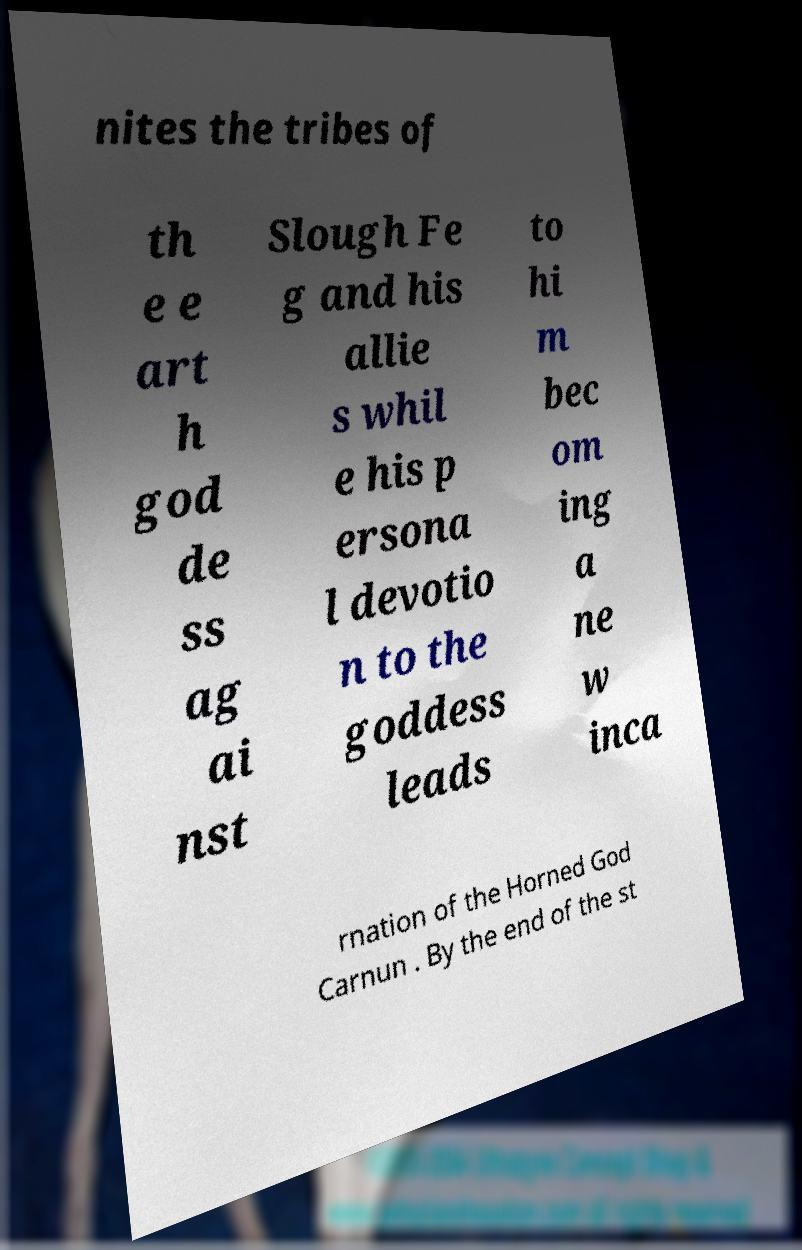I need the written content from this picture converted into text. Can you do that? nites the tribes of th e e art h god de ss ag ai nst Slough Fe g and his allie s whil e his p ersona l devotio n to the goddess leads to hi m bec om ing a ne w inca rnation of the Horned God Carnun . By the end of the st 